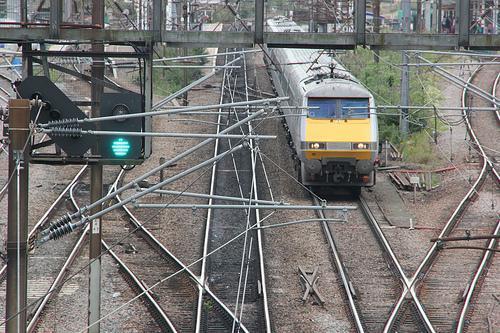How many trains are in the photo?
Give a very brief answer. 1. How many signal lights are there?
Give a very brief answer. 1. 